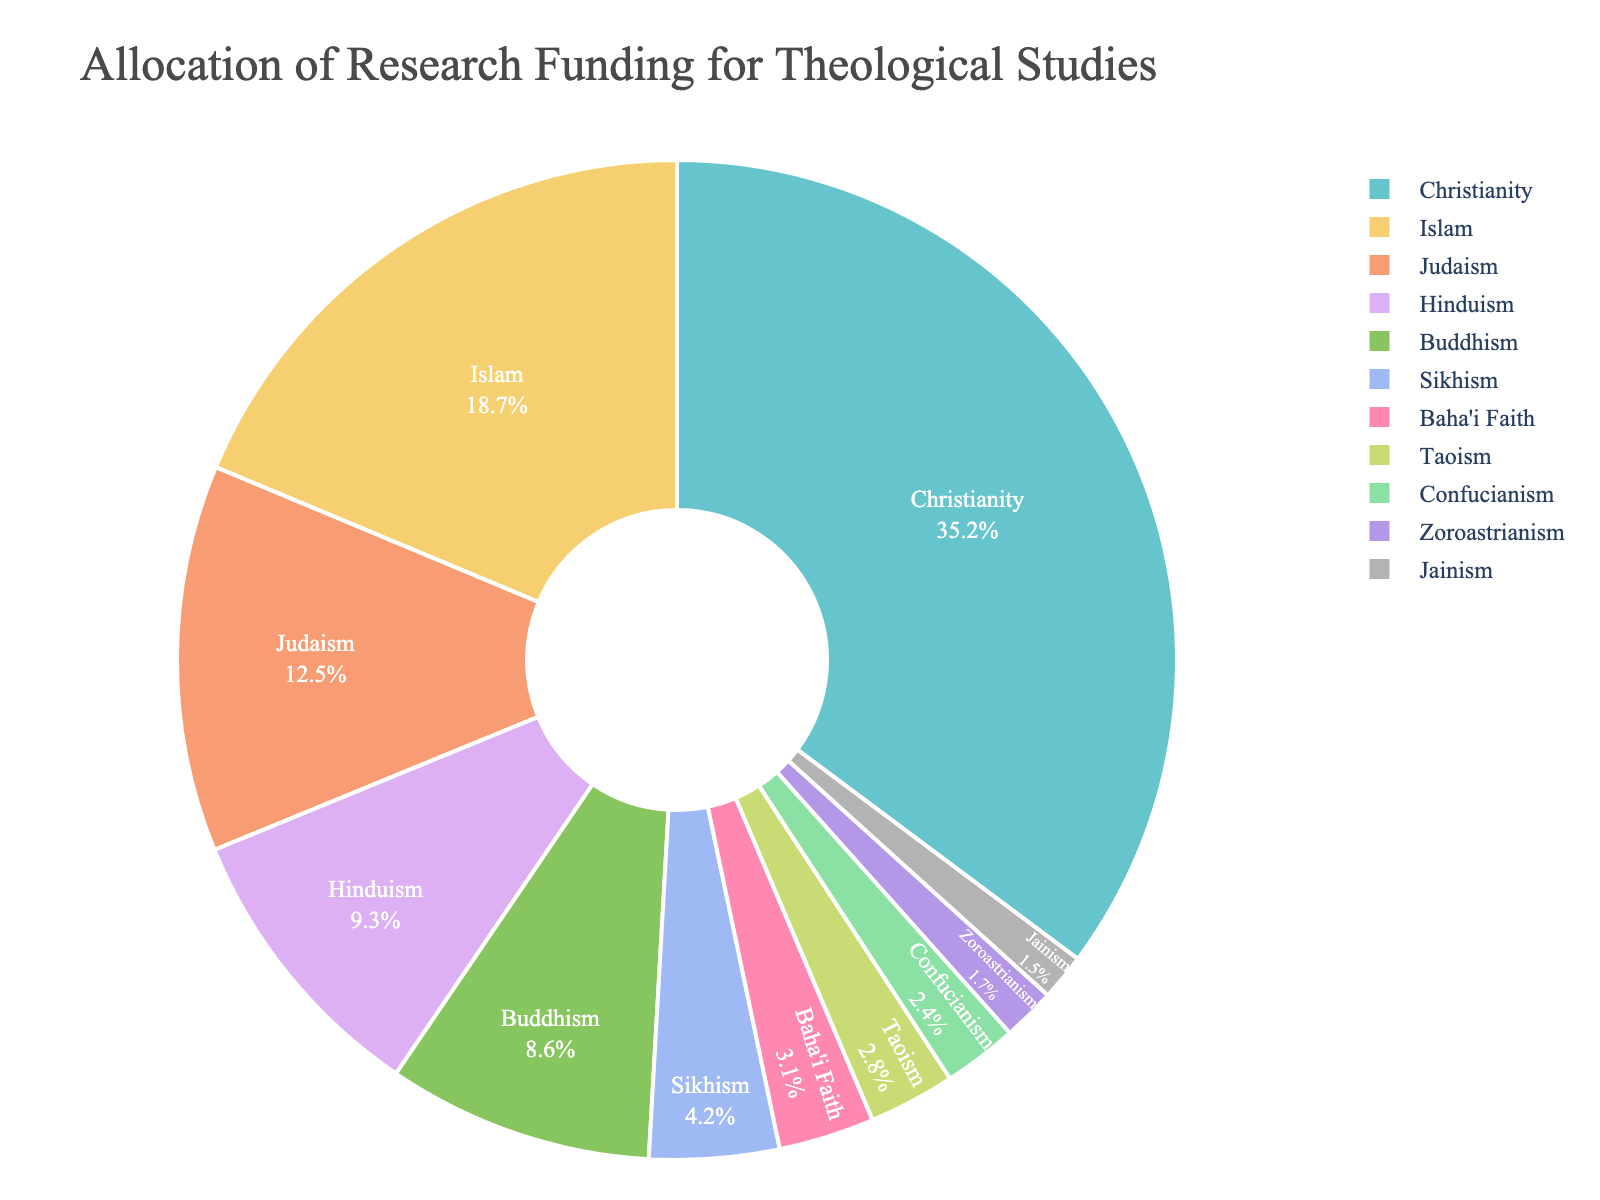Which religion received the most research funding? The pie chart shows that Christianity received the highest funding, indicated by the largest slice.
Answer: Christianity Which religion received the least research funding? The smallest slice in the pie chart represents the religion that received the least funding, which is Jainism.
Answer: Jainism How much more funding did Christianity receive compared to Judaism? Christianity received 35.2%, and Judaism received 12.5%. To find the difference: 35.2% - 12.5% = 22.7%.
Answer: 22.7% What is the combined funding for Hinduism and Buddhism? Hinduism received 9.3% and Buddhism received 8.6%. Summing these percentages gives 9.3% + 8.6% = 17.9%.
Answer: 17.9% Which religions received more research funding than Buddhism? Buddhism received 8.6%. The religions receiving more funding are Christianity (35.2%), Islam (18.7%), Judaism (12.5%), and Hinduism (9.3%).
Answer: Christianity, Islam, Judaism, Hinduism Is the funding allocation for Sikhism greater or less than for Baha'i Faith? By how much? Sikhism received 4.2% funding and Baha'i Faith received 3.1%. To determine if it's greater and by how much: 4.2% - 3.1% = 1.1%. Sikhism received more.
Answer: Greater by 1.1% What percentage of funding is allocated to less than 5% receiving religions? To find out, sum the percentages for Sikhism (4.2%), Baha'i Faith (3.1%), Taoism (2.8%), Confucianism (2.4%), Zoroastrianism (1.7%), and Jainism (1.5%). Total is 4.2% + 3.1% + 2.8% + 2.4% + 1.7% + 1.5% = 15.7%.
Answer: 15.7% What is the difference in funding between the top two religions? Christianity received 35.2% and Islam received 18.7%. The difference is 35.2% - 18.7% = 16.5%.
Answer: 16.5% Is the combined funding for Taoism and Confucianism greater than the funding for Judaism? Taoism received 2.8% and Confucianism received 2.4%. Combined, they received 2.8% + 2.4% = 5.2%. Judaism received 12.5%. Since 5.2% is less than 12.5%, the answer is no.
Answer: No Which religions make up less than 10% of the funding individually? The religions receiving less than 10% individually are Buddhism (8.6%), Sikhism (4.2%), Baha'i Faith (3.1%), Taoism (2.8%), Confucianism (2.4%), Zoroastrianism (1.7%), and Jainism (1.5%).
Answer: Buddhism, Sikhism, Baha'i Faith, Taoism, Confucianism, Zoroastrianism, Jainism 